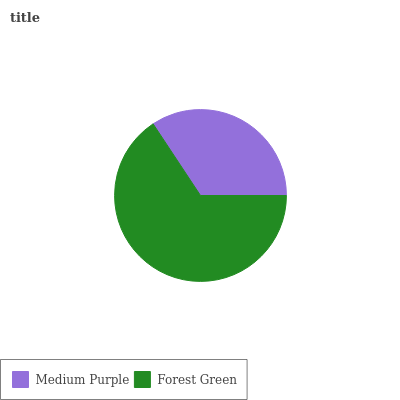Is Medium Purple the minimum?
Answer yes or no. Yes. Is Forest Green the maximum?
Answer yes or no. Yes. Is Forest Green the minimum?
Answer yes or no. No. Is Forest Green greater than Medium Purple?
Answer yes or no. Yes. Is Medium Purple less than Forest Green?
Answer yes or no. Yes. Is Medium Purple greater than Forest Green?
Answer yes or no. No. Is Forest Green less than Medium Purple?
Answer yes or no. No. Is Forest Green the high median?
Answer yes or no. Yes. Is Medium Purple the low median?
Answer yes or no. Yes. Is Medium Purple the high median?
Answer yes or no. No. Is Forest Green the low median?
Answer yes or no. No. 